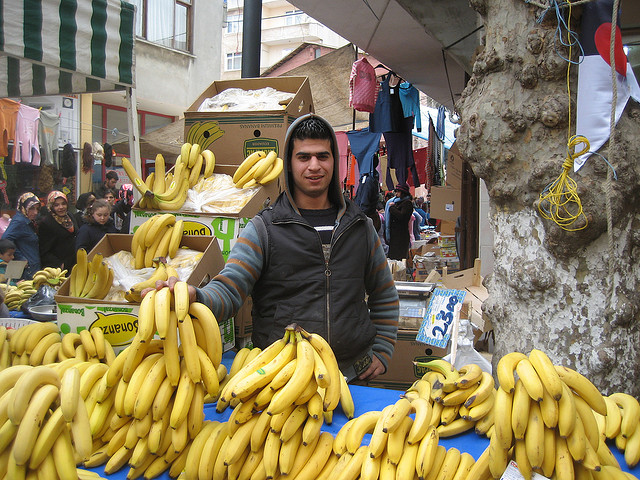Extract all visible text content from this image. 2300 DU 